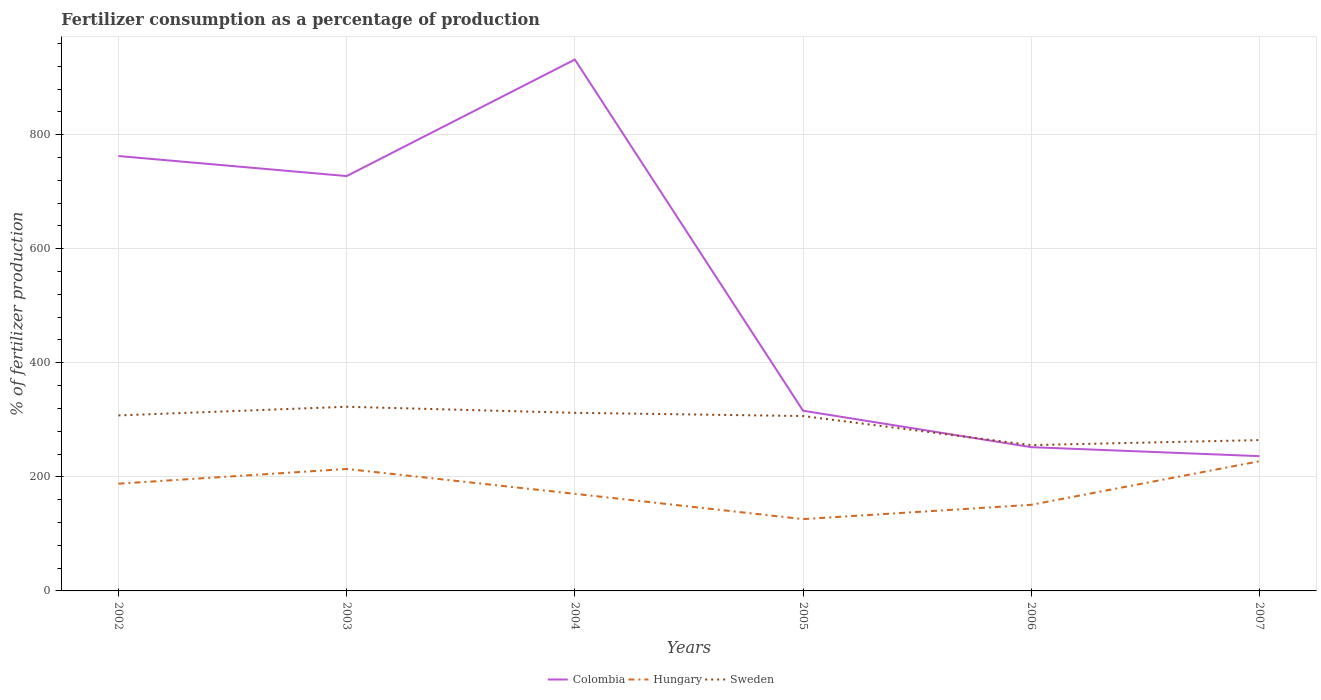How many different coloured lines are there?
Offer a very short reply. 3. Does the line corresponding to Colombia intersect with the line corresponding to Sweden?
Ensure brevity in your answer.  Yes. Is the number of lines equal to the number of legend labels?
Your response must be concise. Yes. Across all years, what is the maximum percentage of fertilizers consumed in Colombia?
Make the answer very short. 236.31. What is the total percentage of fertilizers consumed in Colombia in the graph?
Provide a succinct answer. 475.3. What is the difference between the highest and the second highest percentage of fertilizers consumed in Sweden?
Provide a succinct answer. 67.19. What is the difference between the highest and the lowest percentage of fertilizers consumed in Sweden?
Provide a succinct answer. 4. How many years are there in the graph?
Offer a very short reply. 6. What is the difference between two consecutive major ticks on the Y-axis?
Provide a short and direct response. 200. Are the values on the major ticks of Y-axis written in scientific E-notation?
Your answer should be very brief. No. How many legend labels are there?
Your response must be concise. 3. What is the title of the graph?
Provide a short and direct response. Fertilizer consumption as a percentage of production. Does "Guyana" appear as one of the legend labels in the graph?
Your answer should be very brief. No. What is the label or title of the X-axis?
Provide a succinct answer. Years. What is the label or title of the Y-axis?
Provide a short and direct response. % of fertilizer production. What is the % of fertilizer production in Colombia in 2002?
Provide a succinct answer. 762.5. What is the % of fertilizer production in Hungary in 2002?
Offer a very short reply. 188.03. What is the % of fertilizer production of Sweden in 2002?
Provide a short and direct response. 307.71. What is the % of fertilizer production in Colombia in 2003?
Offer a very short reply. 727.37. What is the % of fertilizer production in Hungary in 2003?
Give a very brief answer. 213.83. What is the % of fertilizer production of Sweden in 2003?
Make the answer very short. 322.88. What is the % of fertilizer production of Colombia in 2004?
Provide a short and direct response. 931.67. What is the % of fertilizer production in Hungary in 2004?
Your answer should be compact. 170.26. What is the % of fertilizer production of Sweden in 2004?
Keep it short and to the point. 312.28. What is the % of fertilizer production of Colombia in 2005?
Ensure brevity in your answer.  315.96. What is the % of fertilizer production of Hungary in 2005?
Keep it short and to the point. 125.92. What is the % of fertilizer production in Sweden in 2005?
Your answer should be very brief. 306.64. What is the % of fertilizer production in Colombia in 2006?
Give a very brief answer. 252.07. What is the % of fertilizer production in Hungary in 2006?
Make the answer very short. 150.99. What is the % of fertilizer production in Sweden in 2006?
Give a very brief answer. 255.69. What is the % of fertilizer production in Colombia in 2007?
Offer a terse response. 236.31. What is the % of fertilizer production in Hungary in 2007?
Keep it short and to the point. 227.39. What is the % of fertilizer production in Sweden in 2007?
Offer a terse response. 264.45. Across all years, what is the maximum % of fertilizer production in Colombia?
Your answer should be compact. 931.67. Across all years, what is the maximum % of fertilizer production in Hungary?
Your answer should be very brief. 227.39. Across all years, what is the maximum % of fertilizer production of Sweden?
Keep it short and to the point. 322.88. Across all years, what is the minimum % of fertilizer production of Colombia?
Provide a short and direct response. 236.31. Across all years, what is the minimum % of fertilizer production of Hungary?
Offer a terse response. 125.92. Across all years, what is the minimum % of fertilizer production in Sweden?
Provide a short and direct response. 255.69. What is the total % of fertilizer production of Colombia in the graph?
Provide a succinct answer. 3225.88. What is the total % of fertilizer production of Hungary in the graph?
Offer a very short reply. 1076.42. What is the total % of fertilizer production in Sweden in the graph?
Provide a succinct answer. 1769.65. What is the difference between the % of fertilizer production of Colombia in 2002 and that in 2003?
Offer a very short reply. 35.14. What is the difference between the % of fertilizer production in Hungary in 2002 and that in 2003?
Provide a succinct answer. -25.81. What is the difference between the % of fertilizer production of Sweden in 2002 and that in 2003?
Give a very brief answer. -15.17. What is the difference between the % of fertilizer production in Colombia in 2002 and that in 2004?
Give a very brief answer. -169.16. What is the difference between the % of fertilizer production of Hungary in 2002 and that in 2004?
Your answer should be compact. 17.77. What is the difference between the % of fertilizer production of Sweden in 2002 and that in 2004?
Provide a short and direct response. -4.57. What is the difference between the % of fertilizer production in Colombia in 2002 and that in 2005?
Your answer should be very brief. 446.55. What is the difference between the % of fertilizer production of Hungary in 2002 and that in 2005?
Make the answer very short. 62.1. What is the difference between the % of fertilizer production in Sweden in 2002 and that in 2005?
Provide a succinct answer. 1.07. What is the difference between the % of fertilizer production of Colombia in 2002 and that in 2006?
Offer a terse response. 510.44. What is the difference between the % of fertilizer production in Hungary in 2002 and that in 2006?
Offer a terse response. 37.03. What is the difference between the % of fertilizer production in Sweden in 2002 and that in 2006?
Ensure brevity in your answer.  52.02. What is the difference between the % of fertilizer production in Colombia in 2002 and that in 2007?
Provide a short and direct response. 526.19. What is the difference between the % of fertilizer production of Hungary in 2002 and that in 2007?
Your response must be concise. -39.36. What is the difference between the % of fertilizer production of Sweden in 2002 and that in 2007?
Offer a very short reply. 43.26. What is the difference between the % of fertilizer production of Colombia in 2003 and that in 2004?
Your answer should be very brief. -204.3. What is the difference between the % of fertilizer production in Hungary in 2003 and that in 2004?
Your answer should be very brief. 43.58. What is the difference between the % of fertilizer production of Sweden in 2003 and that in 2004?
Provide a succinct answer. 10.6. What is the difference between the % of fertilizer production in Colombia in 2003 and that in 2005?
Offer a very short reply. 411.41. What is the difference between the % of fertilizer production of Hungary in 2003 and that in 2005?
Provide a short and direct response. 87.91. What is the difference between the % of fertilizer production of Sweden in 2003 and that in 2005?
Keep it short and to the point. 16.24. What is the difference between the % of fertilizer production of Colombia in 2003 and that in 2006?
Give a very brief answer. 475.3. What is the difference between the % of fertilizer production in Hungary in 2003 and that in 2006?
Your response must be concise. 62.84. What is the difference between the % of fertilizer production in Sweden in 2003 and that in 2006?
Make the answer very short. 67.19. What is the difference between the % of fertilizer production of Colombia in 2003 and that in 2007?
Offer a terse response. 491.06. What is the difference between the % of fertilizer production in Hungary in 2003 and that in 2007?
Ensure brevity in your answer.  -13.55. What is the difference between the % of fertilizer production in Sweden in 2003 and that in 2007?
Give a very brief answer. 58.44. What is the difference between the % of fertilizer production of Colombia in 2004 and that in 2005?
Keep it short and to the point. 615.71. What is the difference between the % of fertilizer production of Hungary in 2004 and that in 2005?
Your response must be concise. 44.33. What is the difference between the % of fertilizer production in Sweden in 2004 and that in 2005?
Ensure brevity in your answer.  5.64. What is the difference between the % of fertilizer production of Colombia in 2004 and that in 2006?
Make the answer very short. 679.6. What is the difference between the % of fertilizer production in Hungary in 2004 and that in 2006?
Keep it short and to the point. 19.26. What is the difference between the % of fertilizer production in Sweden in 2004 and that in 2006?
Offer a terse response. 56.59. What is the difference between the % of fertilizer production of Colombia in 2004 and that in 2007?
Give a very brief answer. 695.36. What is the difference between the % of fertilizer production of Hungary in 2004 and that in 2007?
Provide a succinct answer. -57.13. What is the difference between the % of fertilizer production of Sweden in 2004 and that in 2007?
Ensure brevity in your answer.  47.84. What is the difference between the % of fertilizer production in Colombia in 2005 and that in 2006?
Your answer should be compact. 63.89. What is the difference between the % of fertilizer production of Hungary in 2005 and that in 2006?
Offer a very short reply. -25.07. What is the difference between the % of fertilizer production of Sweden in 2005 and that in 2006?
Give a very brief answer. 50.95. What is the difference between the % of fertilizer production of Colombia in 2005 and that in 2007?
Keep it short and to the point. 79.65. What is the difference between the % of fertilizer production of Hungary in 2005 and that in 2007?
Offer a terse response. -101.46. What is the difference between the % of fertilizer production of Sweden in 2005 and that in 2007?
Your answer should be compact. 42.19. What is the difference between the % of fertilizer production in Colombia in 2006 and that in 2007?
Provide a short and direct response. 15.76. What is the difference between the % of fertilizer production of Hungary in 2006 and that in 2007?
Offer a very short reply. -76.39. What is the difference between the % of fertilizer production in Sweden in 2006 and that in 2007?
Provide a succinct answer. -8.75. What is the difference between the % of fertilizer production in Colombia in 2002 and the % of fertilizer production in Hungary in 2003?
Your answer should be very brief. 548.67. What is the difference between the % of fertilizer production in Colombia in 2002 and the % of fertilizer production in Sweden in 2003?
Provide a short and direct response. 439.62. What is the difference between the % of fertilizer production in Hungary in 2002 and the % of fertilizer production in Sweden in 2003?
Keep it short and to the point. -134.86. What is the difference between the % of fertilizer production of Colombia in 2002 and the % of fertilizer production of Hungary in 2004?
Provide a succinct answer. 592.25. What is the difference between the % of fertilizer production of Colombia in 2002 and the % of fertilizer production of Sweden in 2004?
Give a very brief answer. 450.22. What is the difference between the % of fertilizer production of Hungary in 2002 and the % of fertilizer production of Sweden in 2004?
Ensure brevity in your answer.  -124.26. What is the difference between the % of fertilizer production of Colombia in 2002 and the % of fertilizer production of Hungary in 2005?
Offer a terse response. 636.58. What is the difference between the % of fertilizer production of Colombia in 2002 and the % of fertilizer production of Sweden in 2005?
Provide a short and direct response. 455.86. What is the difference between the % of fertilizer production in Hungary in 2002 and the % of fertilizer production in Sweden in 2005?
Your answer should be compact. -118.61. What is the difference between the % of fertilizer production in Colombia in 2002 and the % of fertilizer production in Hungary in 2006?
Your answer should be very brief. 611.51. What is the difference between the % of fertilizer production of Colombia in 2002 and the % of fertilizer production of Sweden in 2006?
Offer a terse response. 506.81. What is the difference between the % of fertilizer production in Hungary in 2002 and the % of fertilizer production in Sweden in 2006?
Make the answer very short. -67.67. What is the difference between the % of fertilizer production of Colombia in 2002 and the % of fertilizer production of Hungary in 2007?
Offer a very short reply. 535.12. What is the difference between the % of fertilizer production of Colombia in 2002 and the % of fertilizer production of Sweden in 2007?
Make the answer very short. 498.06. What is the difference between the % of fertilizer production of Hungary in 2002 and the % of fertilizer production of Sweden in 2007?
Ensure brevity in your answer.  -76.42. What is the difference between the % of fertilizer production of Colombia in 2003 and the % of fertilizer production of Hungary in 2004?
Make the answer very short. 557.11. What is the difference between the % of fertilizer production in Colombia in 2003 and the % of fertilizer production in Sweden in 2004?
Your answer should be very brief. 415.09. What is the difference between the % of fertilizer production of Hungary in 2003 and the % of fertilizer production of Sweden in 2004?
Your response must be concise. -98.45. What is the difference between the % of fertilizer production of Colombia in 2003 and the % of fertilizer production of Hungary in 2005?
Give a very brief answer. 601.45. What is the difference between the % of fertilizer production of Colombia in 2003 and the % of fertilizer production of Sweden in 2005?
Keep it short and to the point. 420.73. What is the difference between the % of fertilizer production of Hungary in 2003 and the % of fertilizer production of Sweden in 2005?
Give a very brief answer. -92.81. What is the difference between the % of fertilizer production of Colombia in 2003 and the % of fertilizer production of Hungary in 2006?
Your answer should be compact. 576.37. What is the difference between the % of fertilizer production of Colombia in 2003 and the % of fertilizer production of Sweden in 2006?
Make the answer very short. 471.68. What is the difference between the % of fertilizer production of Hungary in 2003 and the % of fertilizer production of Sweden in 2006?
Provide a succinct answer. -41.86. What is the difference between the % of fertilizer production of Colombia in 2003 and the % of fertilizer production of Hungary in 2007?
Make the answer very short. 499.98. What is the difference between the % of fertilizer production of Colombia in 2003 and the % of fertilizer production of Sweden in 2007?
Your answer should be very brief. 462.92. What is the difference between the % of fertilizer production of Hungary in 2003 and the % of fertilizer production of Sweden in 2007?
Provide a succinct answer. -50.61. What is the difference between the % of fertilizer production in Colombia in 2004 and the % of fertilizer production in Hungary in 2005?
Keep it short and to the point. 805.74. What is the difference between the % of fertilizer production in Colombia in 2004 and the % of fertilizer production in Sweden in 2005?
Offer a very short reply. 625.03. What is the difference between the % of fertilizer production of Hungary in 2004 and the % of fertilizer production of Sweden in 2005?
Your response must be concise. -136.38. What is the difference between the % of fertilizer production in Colombia in 2004 and the % of fertilizer production in Hungary in 2006?
Ensure brevity in your answer.  780.67. What is the difference between the % of fertilizer production in Colombia in 2004 and the % of fertilizer production in Sweden in 2006?
Make the answer very short. 675.97. What is the difference between the % of fertilizer production in Hungary in 2004 and the % of fertilizer production in Sweden in 2006?
Give a very brief answer. -85.44. What is the difference between the % of fertilizer production of Colombia in 2004 and the % of fertilizer production of Hungary in 2007?
Your answer should be compact. 704.28. What is the difference between the % of fertilizer production in Colombia in 2004 and the % of fertilizer production in Sweden in 2007?
Provide a short and direct response. 667.22. What is the difference between the % of fertilizer production in Hungary in 2004 and the % of fertilizer production in Sweden in 2007?
Your answer should be compact. -94.19. What is the difference between the % of fertilizer production of Colombia in 2005 and the % of fertilizer production of Hungary in 2006?
Make the answer very short. 164.97. What is the difference between the % of fertilizer production in Colombia in 2005 and the % of fertilizer production in Sweden in 2006?
Keep it short and to the point. 60.27. What is the difference between the % of fertilizer production in Hungary in 2005 and the % of fertilizer production in Sweden in 2006?
Your answer should be compact. -129.77. What is the difference between the % of fertilizer production in Colombia in 2005 and the % of fertilizer production in Hungary in 2007?
Make the answer very short. 88.57. What is the difference between the % of fertilizer production of Colombia in 2005 and the % of fertilizer production of Sweden in 2007?
Your response must be concise. 51.51. What is the difference between the % of fertilizer production of Hungary in 2005 and the % of fertilizer production of Sweden in 2007?
Your answer should be very brief. -138.52. What is the difference between the % of fertilizer production in Colombia in 2006 and the % of fertilizer production in Hungary in 2007?
Keep it short and to the point. 24.68. What is the difference between the % of fertilizer production of Colombia in 2006 and the % of fertilizer production of Sweden in 2007?
Provide a succinct answer. -12.38. What is the difference between the % of fertilizer production of Hungary in 2006 and the % of fertilizer production of Sweden in 2007?
Offer a terse response. -113.45. What is the average % of fertilizer production of Colombia per year?
Provide a succinct answer. 537.65. What is the average % of fertilizer production of Hungary per year?
Offer a terse response. 179.4. What is the average % of fertilizer production of Sweden per year?
Provide a succinct answer. 294.94. In the year 2002, what is the difference between the % of fertilizer production in Colombia and % of fertilizer production in Hungary?
Ensure brevity in your answer.  574.48. In the year 2002, what is the difference between the % of fertilizer production of Colombia and % of fertilizer production of Sweden?
Make the answer very short. 454.79. In the year 2002, what is the difference between the % of fertilizer production in Hungary and % of fertilizer production in Sweden?
Provide a short and direct response. -119.68. In the year 2003, what is the difference between the % of fertilizer production in Colombia and % of fertilizer production in Hungary?
Offer a terse response. 513.54. In the year 2003, what is the difference between the % of fertilizer production in Colombia and % of fertilizer production in Sweden?
Provide a succinct answer. 404.49. In the year 2003, what is the difference between the % of fertilizer production of Hungary and % of fertilizer production of Sweden?
Give a very brief answer. -109.05. In the year 2004, what is the difference between the % of fertilizer production in Colombia and % of fertilizer production in Hungary?
Give a very brief answer. 761.41. In the year 2004, what is the difference between the % of fertilizer production of Colombia and % of fertilizer production of Sweden?
Offer a terse response. 619.38. In the year 2004, what is the difference between the % of fertilizer production of Hungary and % of fertilizer production of Sweden?
Make the answer very short. -142.03. In the year 2005, what is the difference between the % of fertilizer production of Colombia and % of fertilizer production of Hungary?
Your response must be concise. 190.04. In the year 2005, what is the difference between the % of fertilizer production in Colombia and % of fertilizer production in Sweden?
Keep it short and to the point. 9.32. In the year 2005, what is the difference between the % of fertilizer production of Hungary and % of fertilizer production of Sweden?
Your response must be concise. -180.72. In the year 2006, what is the difference between the % of fertilizer production of Colombia and % of fertilizer production of Hungary?
Make the answer very short. 101.08. In the year 2006, what is the difference between the % of fertilizer production of Colombia and % of fertilizer production of Sweden?
Provide a succinct answer. -3.62. In the year 2006, what is the difference between the % of fertilizer production of Hungary and % of fertilizer production of Sweden?
Ensure brevity in your answer.  -104.7. In the year 2007, what is the difference between the % of fertilizer production of Colombia and % of fertilizer production of Hungary?
Provide a short and direct response. 8.92. In the year 2007, what is the difference between the % of fertilizer production in Colombia and % of fertilizer production in Sweden?
Provide a succinct answer. -28.14. In the year 2007, what is the difference between the % of fertilizer production of Hungary and % of fertilizer production of Sweden?
Offer a terse response. -37.06. What is the ratio of the % of fertilizer production in Colombia in 2002 to that in 2003?
Offer a terse response. 1.05. What is the ratio of the % of fertilizer production in Hungary in 2002 to that in 2003?
Your answer should be very brief. 0.88. What is the ratio of the % of fertilizer production in Sweden in 2002 to that in 2003?
Keep it short and to the point. 0.95. What is the ratio of the % of fertilizer production of Colombia in 2002 to that in 2004?
Your answer should be very brief. 0.82. What is the ratio of the % of fertilizer production in Hungary in 2002 to that in 2004?
Your answer should be compact. 1.1. What is the ratio of the % of fertilizer production in Sweden in 2002 to that in 2004?
Your answer should be very brief. 0.99. What is the ratio of the % of fertilizer production in Colombia in 2002 to that in 2005?
Give a very brief answer. 2.41. What is the ratio of the % of fertilizer production of Hungary in 2002 to that in 2005?
Your answer should be compact. 1.49. What is the ratio of the % of fertilizer production in Colombia in 2002 to that in 2006?
Keep it short and to the point. 3.02. What is the ratio of the % of fertilizer production of Hungary in 2002 to that in 2006?
Keep it short and to the point. 1.25. What is the ratio of the % of fertilizer production of Sweden in 2002 to that in 2006?
Your response must be concise. 1.2. What is the ratio of the % of fertilizer production in Colombia in 2002 to that in 2007?
Your answer should be very brief. 3.23. What is the ratio of the % of fertilizer production of Hungary in 2002 to that in 2007?
Your answer should be compact. 0.83. What is the ratio of the % of fertilizer production in Sweden in 2002 to that in 2007?
Provide a succinct answer. 1.16. What is the ratio of the % of fertilizer production in Colombia in 2003 to that in 2004?
Your answer should be compact. 0.78. What is the ratio of the % of fertilizer production in Hungary in 2003 to that in 2004?
Your response must be concise. 1.26. What is the ratio of the % of fertilizer production of Sweden in 2003 to that in 2004?
Make the answer very short. 1.03. What is the ratio of the % of fertilizer production in Colombia in 2003 to that in 2005?
Make the answer very short. 2.3. What is the ratio of the % of fertilizer production of Hungary in 2003 to that in 2005?
Offer a terse response. 1.7. What is the ratio of the % of fertilizer production in Sweden in 2003 to that in 2005?
Your response must be concise. 1.05. What is the ratio of the % of fertilizer production of Colombia in 2003 to that in 2006?
Provide a succinct answer. 2.89. What is the ratio of the % of fertilizer production of Hungary in 2003 to that in 2006?
Ensure brevity in your answer.  1.42. What is the ratio of the % of fertilizer production of Sweden in 2003 to that in 2006?
Keep it short and to the point. 1.26. What is the ratio of the % of fertilizer production of Colombia in 2003 to that in 2007?
Your response must be concise. 3.08. What is the ratio of the % of fertilizer production of Hungary in 2003 to that in 2007?
Your answer should be compact. 0.94. What is the ratio of the % of fertilizer production in Sweden in 2003 to that in 2007?
Your response must be concise. 1.22. What is the ratio of the % of fertilizer production in Colombia in 2004 to that in 2005?
Ensure brevity in your answer.  2.95. What is the ratio of the % of fertilizer production of Hungary in 2004 to that in 2005?
Offer a very short reply. 1.35. What is the ratio of the % of fertilizer production in Sweden in 2004 to that in 2005?
Your answer should be compact. 1.02. What is the ratio of the % of fertilizer production of Colombia in 2004 to that in 2006?
Give a very brief answer. 3.7. What is the ratio of the % of fertilizer production of Hungary in 2004 to that in 2006?
Offer a very short reply. 1.13. What is the ratio of the % of fertilizer production of Sweden in 2004 to that in 2006?
Offer a terse response. 1.22. What is the ratio of the % of fertilizer production of Colombia in 2004 to that in 2007?
Your answer should be compact. 3.94. What is the ratio of the % of fertilizer production in Hungary in 2004 to that in 2007?
Make the answer very short. 0.75. What is the ratio of the % of fertilizer production in Sweden in 2004 to that in 2007?
Provide a succinct answer. 1.18. What is the ratio of the % of fertilizer production in Colombia in 2005 to that in 2006?
Make the answer very short. 1.25. What is the ratio of the % of fertilizer production in Hungary in 2005 to that in 2006?
Offer a terse response. 0.83. What is the ratio of the % of fertilizer production in Sweden in 2005 to that in 2006?
Your answer should be very brief. 1.2. What is the ratio of the % of fertilizer production in Colombia in 2005 to that in 2007?
Ensure brevity in your answer.  1.34. What is the ratio of the % of fertilizer production in Hungary in 2005 to that in 2007?
Your answer should be very brief. 0.55. What is the ratio of the % of fertilizer production in Sweden in 2005 to that in 2007?
Give a very brief answer. 1.16. What is the ratio of the % of fertilizer production in Colombia in 2006 to that in 2007?
Your response must be concise. 1.07. What is the ratio of the % of fertilizer production in Hungary in 2006 to that in 2007?
Offer a terse response. 0.66. What is the ratio of the % of fertilizer production of Sweden in 2006 to that in 2007?
Make the answer very short. 0.97. What is the difference between the highest and the second highest % of fertilizer production of Colombia?
Offer a terse response. 169.16. What is the difference between the highest and the second highest % of fertilizer production in Hungary?
Offer a very short reply. 13.55. What is the difference between the highest and the second highest % of fertilizer production in Sweden?
Your answer should be compact. 10.6. What is the difference between the highest and the lowest % of fertilizer production in Colombia?
Your response must be concise. 695.36. What is the difference between the highest and the lowest % of fertilizer production of Hungary?
Your response must be concise. 101.46. What is the difference between the highest and the lowest % of fertilizer production in Sweden?
Your answer should be very brief. 67.19. 